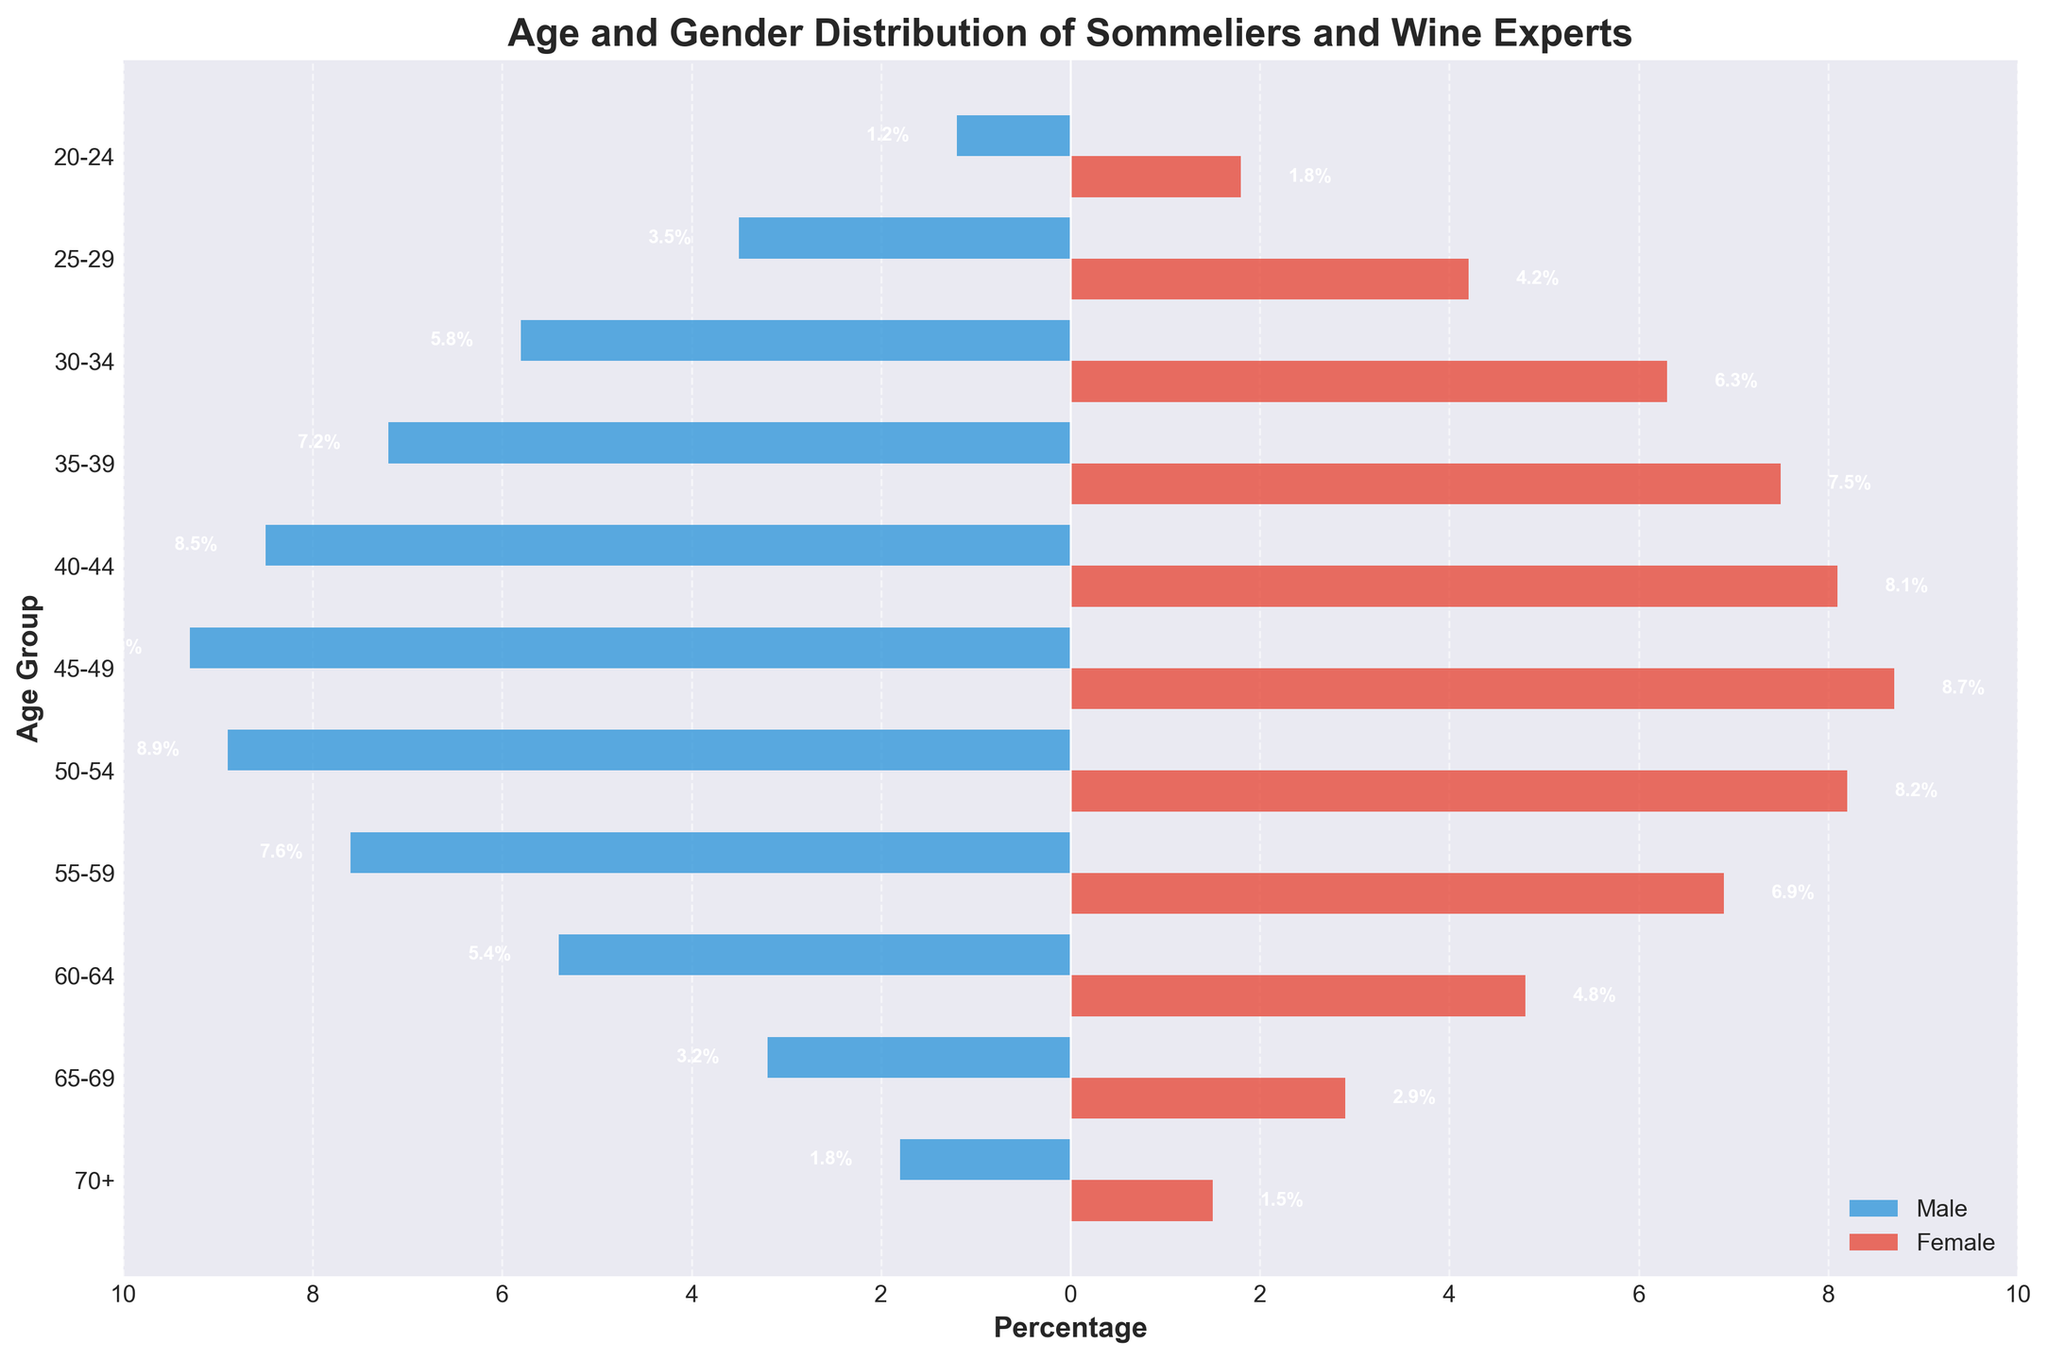How many age groups are illustrated in the figure? Count the age groups listed on the y-axis. There are 11 age groups from '20-24' to '70+'.
Answer: 11 What age group has the highest percentage of male sommeliers and wine experts? Locate the bar reaching furthest to the left for the male population. The '45-49' age group has the highest percentage at 9.3%.
Answer: 45-49 Compare the percentages of female sommeliers and wine experts in the '35-39' and '40-44' age groups. Look at the lengths of the bars for females in these age groups. The '35-39' group has 7.5% and the '40-44' has 8.1%.
Answer: 40-44 is higher Is there a gender that has a higher percentage in the '25-29' age group? Compare the bars for both genders in this age group. Females have a higher percentage at 4.2% compared to 3.5% for males.
Answer: Female What is the percentage difference between males and females in the '50-54' age group? Calculate the absolute difference between the bars of both genders. The male percentage is 8.9% and the female is 8.2%. Difference is 8.9% - 8.2% = 0.7%.
Answer: 0.7% Which age group shows the closest percentage between males and females? Compare the percentages for both genders in each age group and find the smallest difference. The '50-54' age group shows the closest with a difference of 0.7%.
Answer: 50-54 For the '60-64' age group, how much higher is the male percentage compared to the female percentage? Subtract the female percentage from the male percentage in this age group. 5.4% - 4.8% = 0.6%.
Answer: 0.6% What age group has the lowest percentage of female sommeliers and wine experts? Look at the bars for females and identify the shortest. The '70+' group has the lowest percentage at 1.5%.
Answer: 70+ What is the trend of percentages for male sommeliers and wine experts from the '20-24' age group to the '45-49' age group? Observe the bars for males from the '20-24' to the '45-49' groups. The percentage generally increases from 1.2% to 9.3%.
Answer: Increasing Which gender has a higher maximum percentage in any age group? Compare the highest percentages for both genders. Males' highest is 9.3% in '45-49' and females' highest is 8.7% in '45-49'. Males have a higher maximum percentage.
Answer: Males 